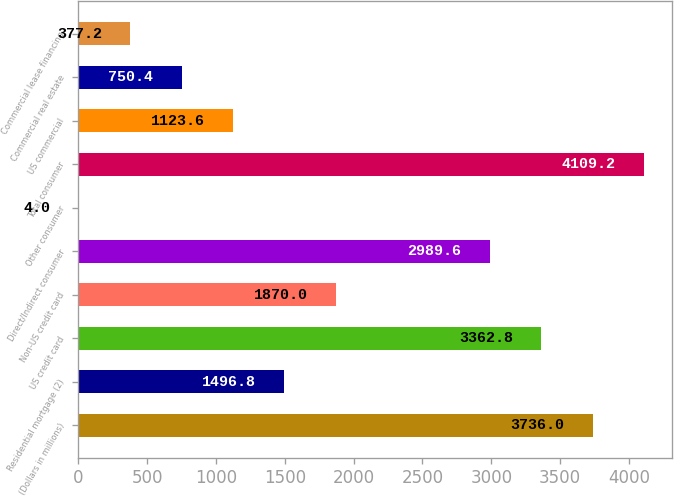Convert chart. <chart><loc_0><loc_0><loc_500><loc_500><bar_chart><fcel>(Dollars in millions)<fcel>Residential mortgage (2)<fcel>US credit card<fcel>Non-US credit card<fcel>Direct/Indirect consumer<fcel>Other consumer<fcel>Total consumer<fcel>US commercial<fcel>Commercial real estate<fcel>Commercial lease financing<nl><fcel>3736<fcel>1496.8<fcel>3362.8<fcel>1870<fcel>2989.6<fcel>4<fcel>4109.2<fcel>1123.6<fcel>750.4<fcel>377.2<nl></chart> 